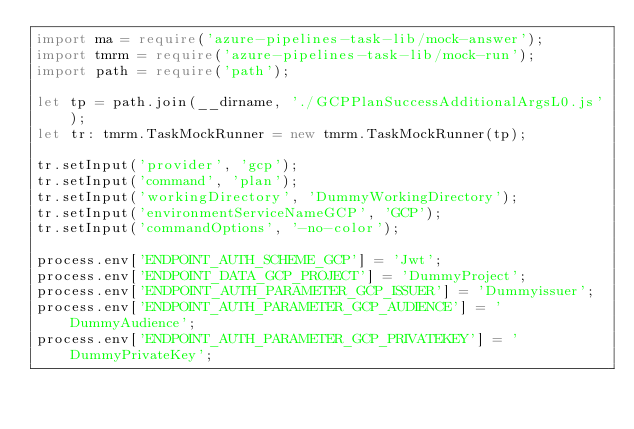<code> <loc_0><loc_0><loc_500><loc_500><_TypeScript_>import ma = require('azure-pipelines-task-lib/mock-answer');
import tmrm = require('azure-pipelines-task-lib/mock-run');
import path = require('path');

let tp = path.join(__dirname, './GCPPlanSuccessAdditionalArgsL0.js');
let tr: tmrm.TaskMockRunner = new tmrm.TaskMockRunner(tp);

tr.setInput('provider', 'gcp');
tr.setInput('command', 'plan');
tr.setInput('workingDirectory', 'DummyWorkingDirectory');
tr.setInput('environmentServiceNameGCP', 'GCP');
tr.setInput('commandOptions', '-no-color');

process.env['ENDPOINT_AUTH_SCHEME_GCP'] = 'Jwt';
process.env['ENDPOINT_DATA_GCP_PROJECT'] = 'DummyProject';
process.env['ENDPOINT_AUTH_PARAMETER_GCP_ISSUER'] = 'Dummyissuer';
process.env['ENDPOINT_AUTH_PARAMETER_GCP_AUDIENCE'] = 'DummyAudience';
process.env['ENDPOINT_AUTH_PARAMETER_GCP_PRIVATEKEY'] = 'DummyPrivateKey';</code> 